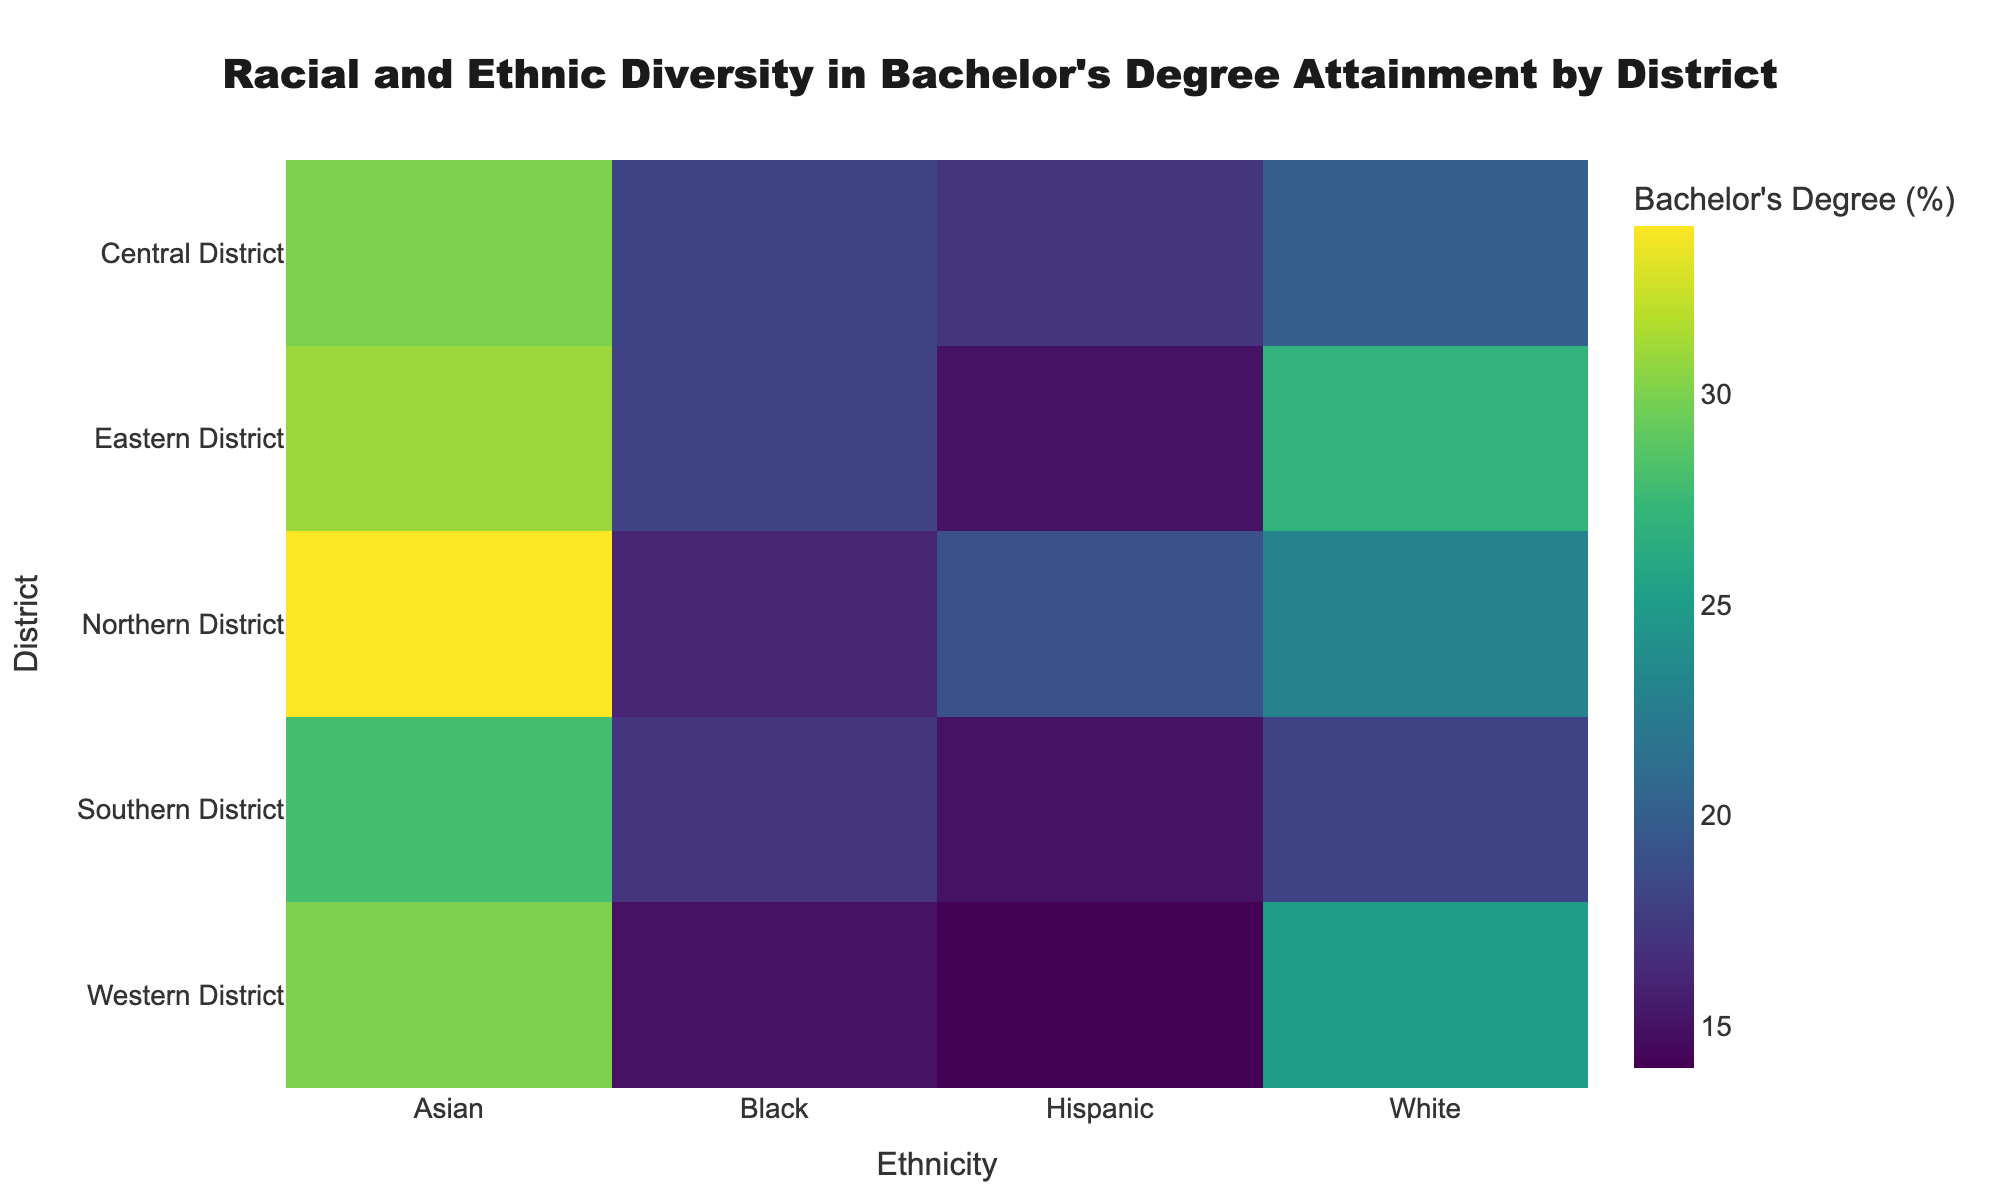What is the title of the heatmap? The title of a figure is usually placed on top of the chart, it summarizes the primary content. Here, it is written in bold for emphasis.
Answer: Racial and Ethnic Diversity in Bachelor's Degree Attainment by District Which district has the highest percentage of Bachelor's degree attainment for Asian ethnicity? Identify the cell within the heatmap where the district is listed in the row, and the Asian ethnicity is in the column, then check for the highest value.
Answer: Northern District Compare the percentage of Bachelor's degree attainment for White ethnicity between Eastern and Western Districts. Which district has a higher percentage and by how much? Check the cells where rows intersect with Eastern and Western Districts under the column for White ethnicity, then subtract the lower value from the higher one.
Answer: Eastern District has 2% higher Which ethnicity has the least Bachelor's degree attainment in the Southern District? From the Southern District row, find the lowest value across all ethnicities' columns.
Answer: Hispanic What is the average Bachelor's degree attainment percentage across all districts for Hispanic ethnicity? Sum the percentages for Hispanic ethnicity across all districts and divide by the number of districts (which is 5). 17 (Central) + 19 (Northern) + 15 (Southern) + 15 (Eastern) + 14 (Western) = 80. Then divide 80 by 5.
Answer: 16 Is there a district where the Bachelor's degree attainment percentage is equal for White and Black ethnicities? Identify rows where both White and Black columns have the same value.
Answer: No Which district has the largest disparity in Bachelor's degree attainment percentage between Black and Asian ethnicities? Calculate the difference between Black and Asian percentages for each district and find the district with the highest difference.
Answer: Northern How does the Central District's Bachelor's degree attainment for Hispanic ethnicity compare to the Western District? Subtract the value of Western District from the value of Central District for Hispanic ethnicity.
Answer: 3% higher in Central By how much does the highest Bachelor's degree attainment among all ethnicities and districts surpass the lowest one? Find the maximum and minimum values across all cells, then subtract the minimum value from the maximum value.
Answer: 34% - 3% = 31% Which ethnicity in the Northern District has a Bachelor's degree attainment percentage closest to the overall average for all ethnicities and districts? Calculate the total average for all cells then find the closest percentage in the Northern District row.
Answer: Asian 